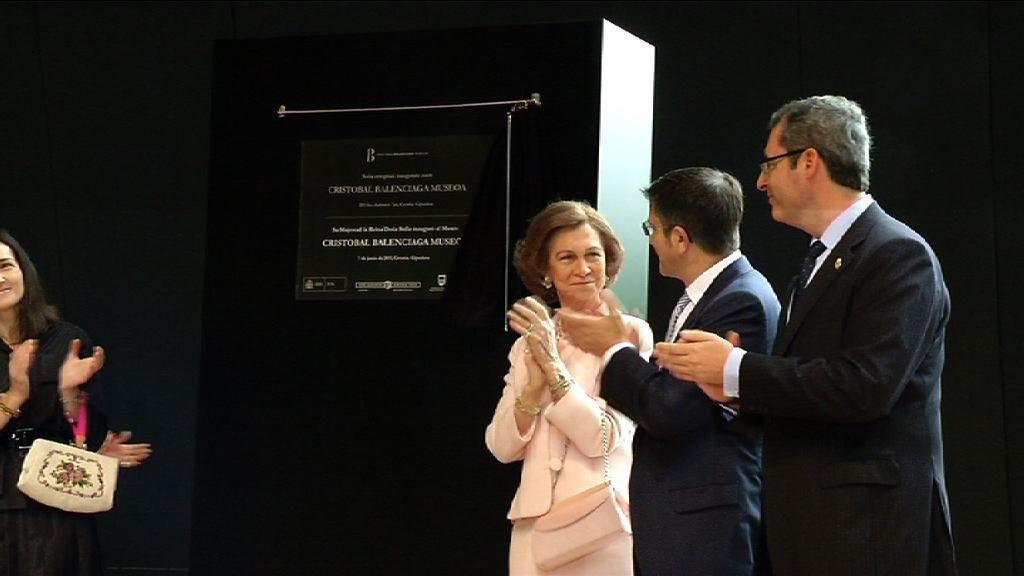Describe this image in one or two sentences. On the right there is a woman and two men standing and clapping. In the background there is a board on an object. On the left there is a woman carrying a bag on her hand and we can see a person hands. 